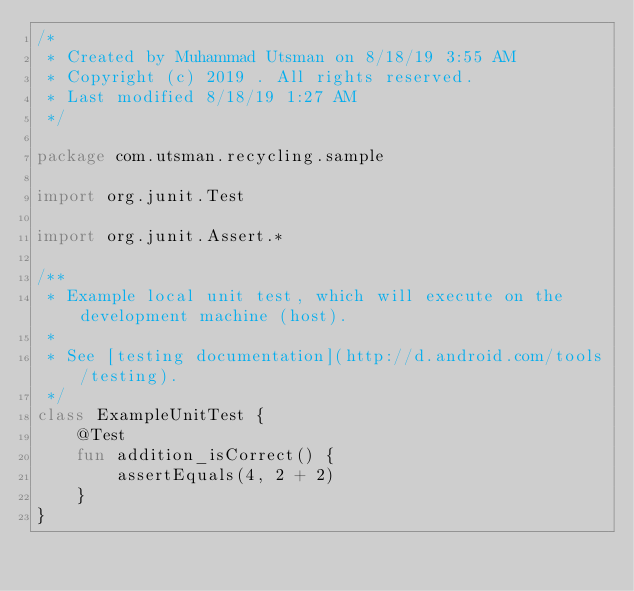Convert code to text. <code><loc_0><loc_0><loc_500><loc_500><_Kotlin_>/*
 * Created by Muhammad Utsman on 8/18/19 3:55 AM
 * Copyright (c) 2019 . All rights reserved.
 * Last modified 8/18/19 1:27 AM
 */

package com.utsman.recycling.sample

import org.junit.Test

import org.junit.Assert.*

/**
 * Example local unit test, which will execute on the development machine (host).
 *
 * See [testing documentation](http://d.android.com/tools/testing).
 */
class ExampleUnitTest {
    @Test
    fun addition_isCorrect() {
        assertEquals(4, 2 + 2)
    }
}
</code> 